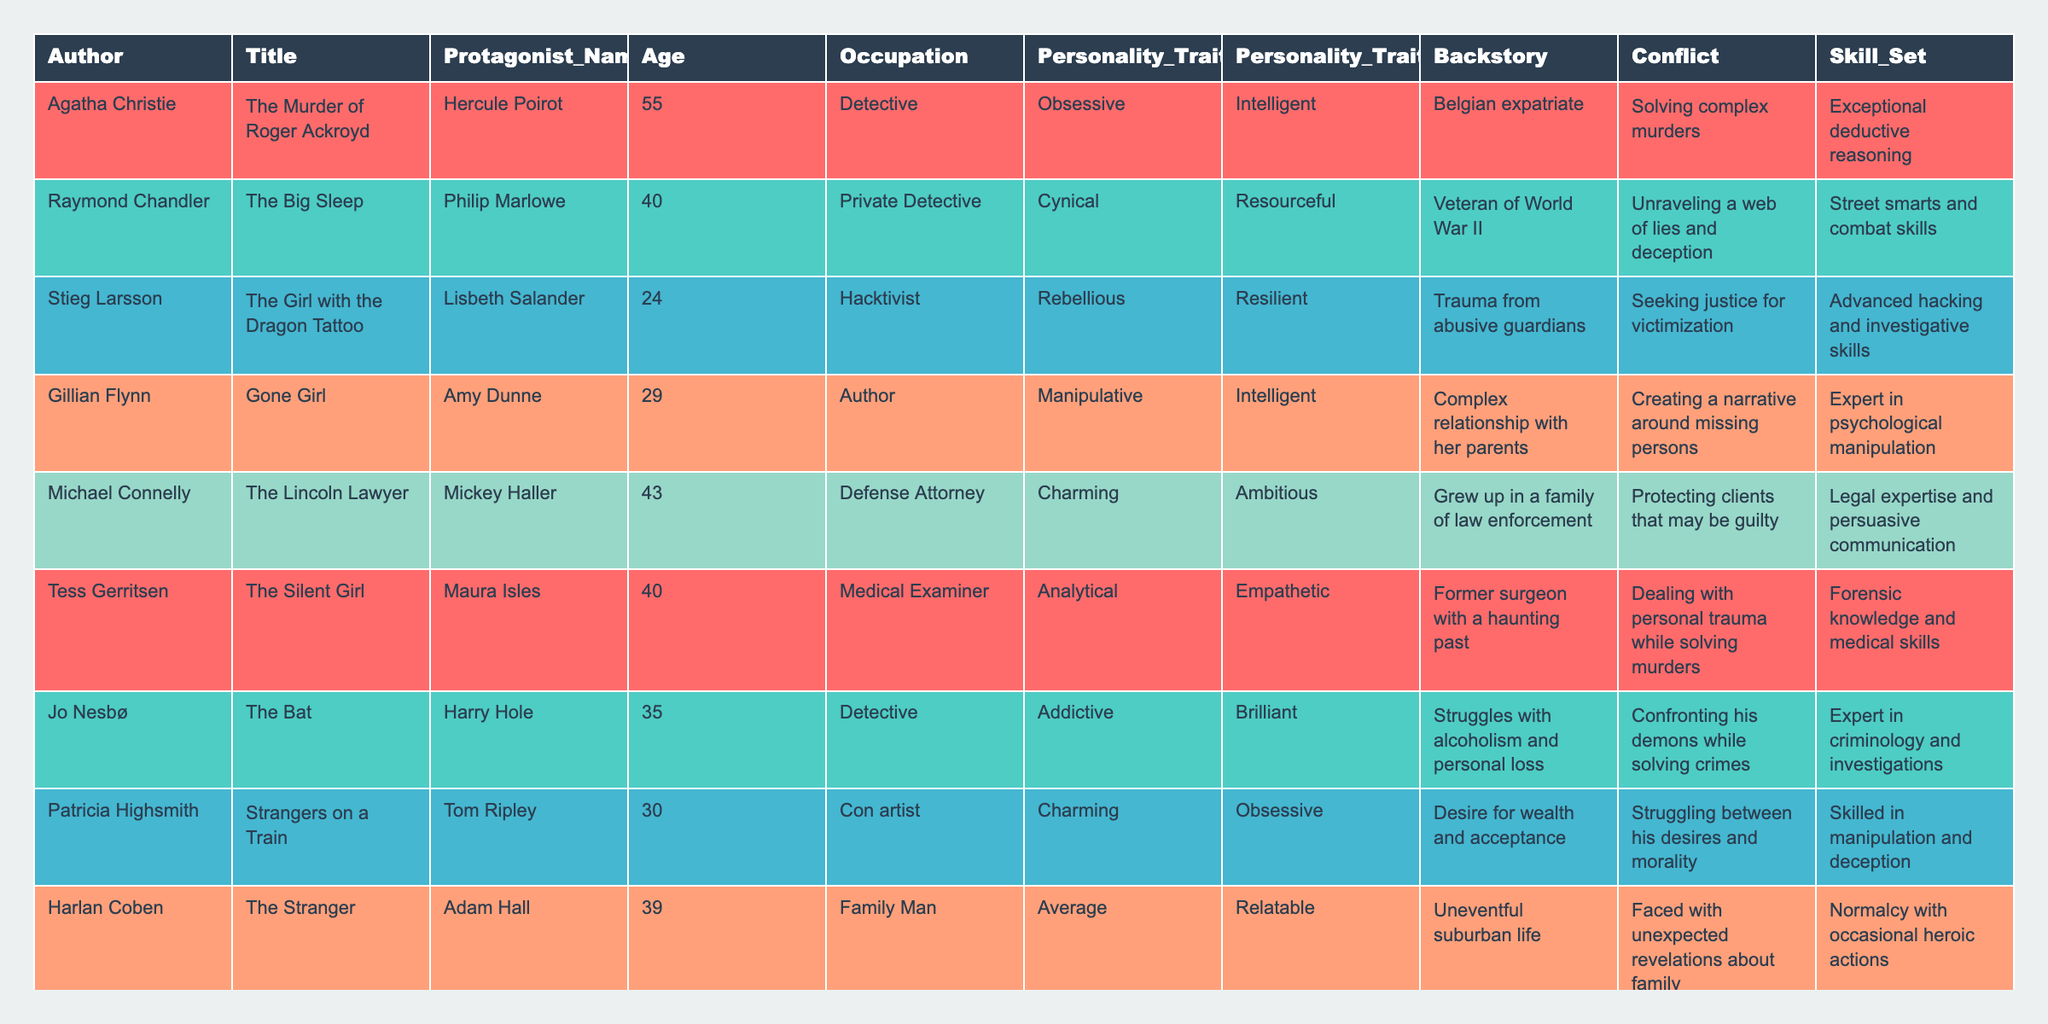What is the age of Hercule Poirot? Hercule Poirot is listed in the table under the "Protagonist_Name" column, and his age is provided in the corresponding age column. The age is 55.
Answer: 55 Which protagonist is a "Private Detective"? The table lists various occupations for the protagonists. By checking the "Occupation" column, we can see that Philip Marlowe, listed as a protagonist, has the occupation of "Private Detective."
Answer: Philip Marlowe How many protagonists are in their 30s? By examining the ages in the "Age" column, we can identify the following protagonists in their 30s: Amy Dunne (29), Tom Ripley (30), Alex Cross (30). Counting these, there are three such protagonists.
Answer: 3 Is Lisbeth Salander described as “Cynical”? We refer to the "Personality_Trait_1" column where Lisbeth Salander's traits are listed. She is described as "Rebellious," not "Cynical." Therefore, the statement is false.
Answer: No Which protagonist has the "Analytical" personality trait and what is their occupation? By searching the "Personality_Trait_1" column for "Analytical," we find Maura Isles. In the same row, the "Occupation" column indicates her occupation is "Medical Examiner."
Answer: Maura Isles, Medical Examiner Who is the youngest protagonist? The ages of the protagonists are found in the "Age" column. By reviewing the values, Lisbeth Salander is the youngest at age 24.
Answer: Lisbeth Salander What is the conflict faced by Mickey Haller? Looking at the "Conflict" column for Mickey Haller, we see that his conflict involves "Protecting clients that may be guilty." This indicates the tension he experiences in his role as a defense attorney.
Answer: Protecting clients that may be guilty How many protagonists have a military background? By examining the "Backstory" column, we identify Philip Marlowe as a veteran of World War II and Harry Hole who struggled with personal loss possibly related to a military background. There are two protagonists with identifiable military backgrounds.
Answer: 2 What skills does Harry Hole possess? The "Skill_Set" column lists Harry Hole’s skills, where it states he has "Expert in criminology and investigations." This tells us about his expertise as a detective.
Answer: Expert in criminology and investigations Which author's protagonist has traumatic relationships in their backstory? By looking at the "Backstory" column, Amy Dunne is noted to have a "Complex relationship with her parents," indicating trauma related to familial relationships, which corresponds to Gillian Flynn, the author's name.
Answer: Gillian Flynn, Amy Dunne 